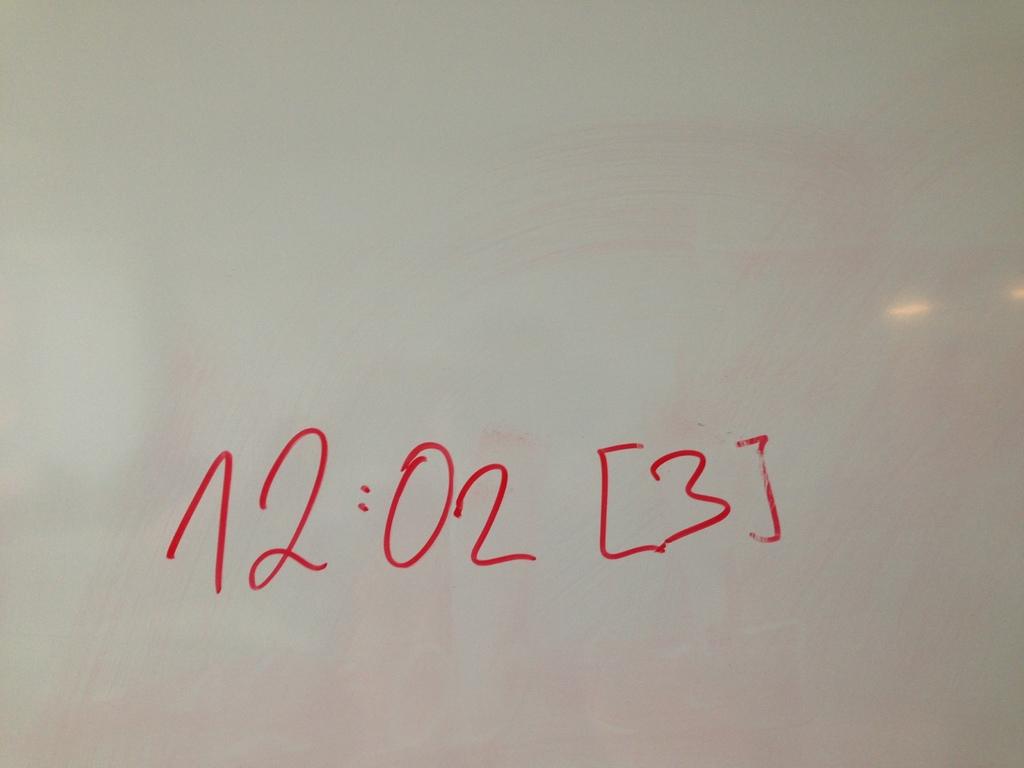What time is listed?
Your response must be concise. 12:02. What number is contained in the brackets?
Your response must be concise. 3. 